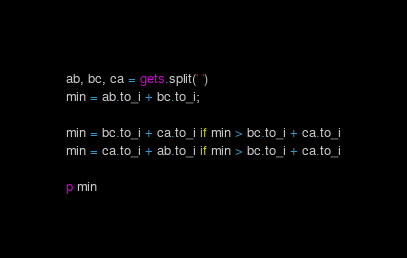Convert code to text. <code><loc_0><loc_0><loc_500><loc_500><_Ruby_>ab, bc, ca = gets.split(' ')
min = ab.to_i + bc.to_i;

min = bc.to_i + ca.to_i if min > bc.to_i + ca.to_i
min = ca.to_i + ab.to_i if min > bc.to_i + ca.to_i

p min</code> 